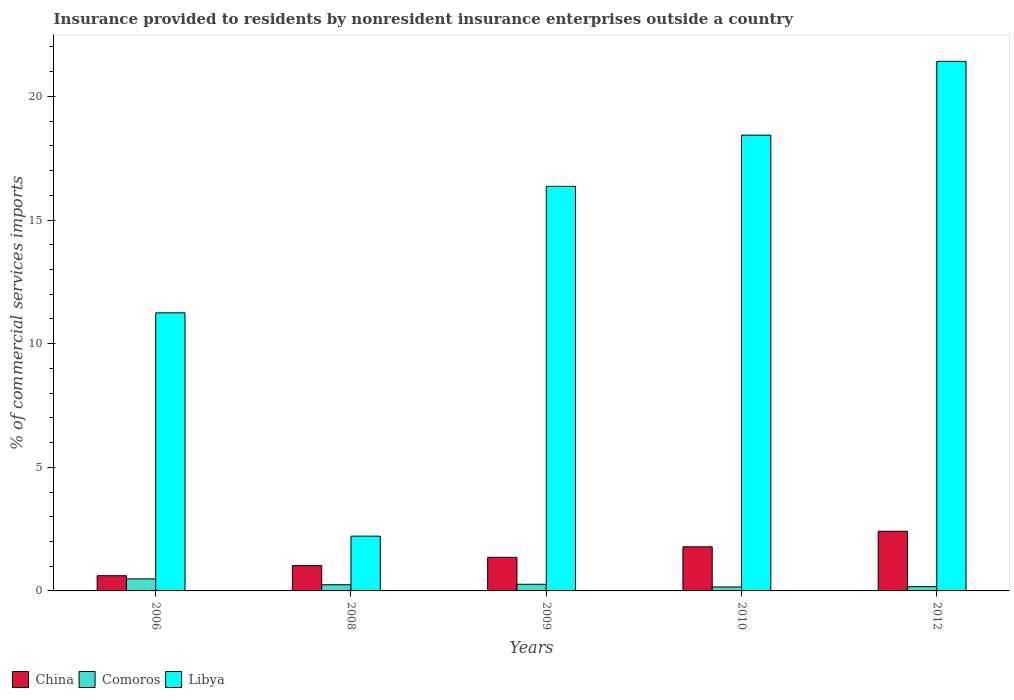How many bars are there on the 2nd tick from the left?
Offer a terse response. 3. What is the Insurance provided to residents in China in 2009?
Offer a terse response. 1.36. Across all years, what is the maximum Insurance provided to residents in China?
Your answer should be very brief. 2.41. Across all years, what is the minimum Insurance provided to residents in Libya?
Ensure brevity in your answer.  2.21. In which year was the Insurance provided to residents in China maximum?
Provide a short and direct response. 2012. In which year was the Insurance provided to residents in China minimum?
Provide a succinct answer. 2006. What is the total Insurance provided to residents in China in the graph?
Offer a terse response. 7.19. What is the difference between the Insurance provided to residents in China in 2006 and that in 2008?
Offer a terse response. -0.41. What is the difference between the Insurance provided to residents in Libya in 2009 and the Insurance provided to residents in Comoros in 2012?
Make the answer very short. 16.19. What is the average Insurance provided to residents in China per year?
Ensure brevity in your answer.  1.44. In the year 2010, what is the difference between the Insurance provided to residents in Libya and Insurance provided to residents in Comoros?
Give a very brief answer. 18.27. What is the ratio of the Insurance provided to residents in Libya in 2009 to that in 2010?
Your answer should be very brief. 0.89. Is the Insurance provided to residents in Libya in 2006 less than that in 2009?
Provide a succinct answer. Yes. Is the difference between the Insurance provided to residents in Libya in 2009 and 2010 greater than the difference between the Insurance provided to residents in Comoros in 2009 and 2010?
Offer a very short reply. No. What is the difference between the highest and the second highest Insurance provided to residents in China?
Give a very brief answer. 0.63. What is the difference between the highest and the lowest Insurance provided to residents in China?
Ensure brevity in your answer.  1.8. What does the 1st bar from the right in 2008 represents?
Make the answer very short. Libya. How many bars are there?
Keep it short and to the point. 15. Are all the bars in the graph horizontal?
Your answer should be compact. No. How many years are there in the graph?
Make the answer very short. 5. Where does the legend appear in the graph?
Your answer should be compact. Bottom left. How many legend labels are there?
Give a very brief answer. 3. How are the legend labels stacked?
Your answer should be very brief. Horizontal. What is the title of the graph?
Your answer should be compact. Insurance provided to residents by nonresident insurance enterprises outside a country. Does "Lower middle income" appear as one of the legend labels in the graph?
Offer a very short reply. No. What is the label or title of the X-axis?
Make the answer very short. Years. What is the label or title of the Y-axis?
Keep it short and to the point. % of commercial services imports. What is the % of commercial services imports of China in 2006?
Make the answer very short. 0.62. What is the % of commercial services imports in Comoros in 2006?
Your response must be concise. 0.49. What is the % of commercial services imports in Libya in 2006?
Keep it short and to the point. 11.25. What is the % of commercial services imports in China in 2008?
Ensure brevity in your answer.  1.02. What is the % of commercial services imports in Comoros in 2008?
Your answer should be very brief. 0.25. What is the % of commercial services imports of Libya in 2008?
Keep it short and to the point. 2.21. What is the % of commercial services imports in China in 2009?
Your response must be concise. 1.36. What is the % of commercial services imports in Comoros in 2009?
Your answer should be compact. 0.27. What is the % of commercial services imports in Libya in 2009?
Your answer should be very brief. 16.36. What is the % of commercial services imports of China in 2010?
Make the answer very short. 1.78. What is the % of commercial services imports in Comoros in 2010?
Give a very brief answer. 0.16. What is the % of commercial services imports in Libya in 2010?
Give a very brief answer. 18.43. What is the % of commercial services imports of China in 2012?
Your response must be concise. 2.41. What is the % of commercial services imports in Comoros in 2012?
Your response must be concise. 0.17. What is the % of commercial services imports of Libya in 2012?
Offer a very short reply. 21.42. Across all years, what is the maximum % of commercial services imports of China?
Give a very brief answer. 2.41. Across all years, what is the maximum % of commercial services imports of Comoros?
Ensure brevity in your answer.  0.49. Across all years, what is the maximum % of commercial services imports in Libya?
Your answer should be compact. 21.42. Across all years, what is the minimum % of commercial services imports of China?
Give a very brief answer. 0.62. Across all years, what is the minimum % of commercial services imports in Comoros?
Ensure brevity in your answer.  0.16. Across all years, what is the minimum % of commercial services imports in Libya?
Ensure brevity in your answer.  2.21. What is the total % of commercial services imports of China in the graph?
Ensure brevity in your answer.  7.19. What is the total % of commercial services imports of Comoros in the graph?
Your response must be concise. 1.34. What is the total % of commercial services imports in Libya in the graph?
Make the answer very short. 69.68. What is the difference between the % of commercial services imports in China in 2006 and that in 2008?
Offer a very short reply. -0.41. What is the difference between the % of commercial services imports in Comoros in 2006 and that in 2008?
Ensure brevity in your answer.  0.24. What is the difference between the % of commercial services imports of Libya in 2006 and that in 2008?
Ensure brevity in your answer.  9.03. What is the difference between the % of commercial services imports in China in 2006 and that in 2009?
Provide a succinct answer. -0.74. What is the difference between the % of commercial services imports of Comoros in 2006 and that in 2009?
Your answer should be very brief. 0.22. What is the difference between the % of commercial services imports in Libya in 2006 and that in 2009?
Your response must be concise. -5.12. What is the difference between the % of commercial services imports in China in 2006 and that in 2010?
Your response must be concise. -1.17. What is the difference between the % of commercial services imports in Comoros in 2006 and that in 2010?
Provide a succinct answer. 0.33. What is the difference between the % of commercial services imports in Libya in 2006 and that in 2010?
Provide a succinct answer. -7.19. What is the difference between the % of commercial services imports of China in 2006 and that in 2012?
Provide a succinct answer. -1.8. What is the difference between the % of commercial services imports of Comoros in 2006 and that in 2012?
Provide a succinct answer. 0.32. What is the difference between the % of commercial services imports of Libya in 2006 and that in 2012?
Provide a succinct answer. -10.17. What is the difference between the % of commercial services imports of China in 2008 and that in 2009?
Provide a succinct answer. -0.34. What is the difference between the % of commercial services imports of Comoros in 2008 and that in 2009?
Ensure brevity in your answer.  -0.02. What is the difference between the % of commercial services imports in Libya in 2008 and that in 2009?
Your answer should be compact. -14.15. What is the difference between the % of commercial services imports of China in 2008 and that in 2010?
Offer a terse response. -0.76. What is the difference between the % of commercial services imports of Comoros in 2008 and that in 2010?
Make the answer very short. 0.09. What is the difference between the % of commercial services imports in Libya in 2008 and that in 2010?
Provide a short and direct response. -16.22. What is the difference between the % of commercial services imports in China in 2008 and that in 2012?
Your answer should be compact. -1.39. What is the difference between the % of commercial services imports of Comoros in 2008 and that in 2012?
Offer a terse response. 0.08. What is the difference between the % of commercial services imports of Libya in 2008 and that in 2012?
Make the answer very short. -19.2. What is the difference between the % of commercial services imports in China in 2009 and that in 2010?
Offer a terse response. -0.42. What is the difference between the % of commercial services imports in Comoros in 2009 and that in 2010?
Your answer should be very brief. 0.11. What is the difference between the % of commercial services imports of Libya in 2009 and that in 2010?
Make the answer very short. -2.07. What is the difference between the % of commercial services imports of China in 2009 and that in 2012?
Your answer should be very brief. -1.05. What is the difference between the % of commercial services imports of Comoros in 2009 and that in 2012?
Offer a terse response. 0.1. What is the difference between the % of commercial services imports of Libya in 2009 and that in 2012?
Make the answer very short. -5.06. What is the difference between the % of commercial services imports of China in 2010 and that in 2012?
Keep it short and to the point. -0.63. What is the difference between the % of commercial services imports in Comoros in 2010 and that in 2012?
Offer a very short reply. -0.01. What is the difference between the % of commercial services imports in Libya in 2010 and that in 2012?
Ensure brevity in your answer.  -2.98. What is the difference between the % of commercial services imports in China in 2006 and the % of commercial services imports in Comoros in 2008?
Make the answer very short. 0.37. What is the difference between the % of commercial services imports in China in 2006 and the % of commercial services imports in Libya in 2008?
Offer a very short reply. -1.6. What is the difference between the % of commercial services imports in Comoros in 2006 and the % of commercial services imports in Libya in 2008?
Provide a short and direct response. -1.73. What is the difference between the % of commercial services imports of China in 2006 and the % of commercial services imports of Comoros in 2009?
Offer a terse response. 0.35. What is the difference between the % of commercial services imports of China in 2006 and the % of commercial services imports of Libya in 2009?
Provide a succinct answer. -15.75. What is the difference between the % of commercial services imports of Comoros in 2006 and the % of commercial services imports of Libya in 2009?
Your answer should be compact. -15.88. What is the difference between the % of commercial services imports in China in 2006 and the % of commercial services imports in Comoros in 2010?
Provide a short and direct response. 0.46. What is the difference between the % of commercial services imports in China in 2006 and the % of commercial services imports in Libya in 2010?
Your answer should be very brief. -17.82. What is the difference between the % of commercial services imports of Comoros in 2006 and the % of commercial services imports of Libya in 2010?
Your answer should be compact. -17.95. What is the difference between the % of commercial services imports in China in 2006 and the % of commercial services imports in Comoros in 2012?
Offer a very short reply. 0.44. What is the difference between the % of commercial services imports of China in 2006 and the % of commercial services imports of Libya in 2012?
Make the answer very short. -20.8. What is the difference between the % of commercial services imports in Comoros in 2006 and the % of commercial services imports in Libya in 2012?
Your answer should be compact. -20.93. What is the difference between the % of commercial services imports of China in 2008 and the % of commercial services imports of Comoros in 2009?
Your answer should be compact. 0.75. What is the difference between the % of commercial services imports of China in 2008 and the % of commercial services imports of Libya in 2009?
Make the answer very short. -15.34. What is the difference between the % of commercial services imports of Comoros in 2008 and the % of commercial services imports of Libya in 2009?
Keep it short and to the point. -16.11. What is the difference between the % of commercial services imports of China in 2008 and the % of commercial services imports of Comoros in 2010?
Provide a succinct answer. 0.86. What is the difference between the % of commercial services imports of China in 2008 and the % of commercial services imports of Libya in 2010?
Offer a very short reply. -17.41. What is the difference between the % of commercial services imports in Comoros in 2008 and the % of commercial services imports in Libya in 2010?
Give a very brief answer. -18.18. What is the difference between the % of commercial services imports in China in 2008 and the % of commercial services imports in Comoros in 2012?
Your response must be concise. 0.85. What is the difference between the % of commercial services imports of China in 2008 and the % of commercial services imports of Libya in 2012?
Provide a succinct answer. -20.4. What is the difference between the % of commercial services imports of Comoros in 2008 and the % of commercial services imports of Libya in 2012?
Your answer should be very brief. -21.17. What is the difference between the % of commercial services imports of China in 2009 and the % of commercial services imports of Comoros in 2010?
Your response must be concise. 1.2. What is the difference between the % of commercial services imports of China in 2009 and the % of commercial services imports of Libya in 2010?
Your answer should be very brief. -17.08. What is the difference between the % of commercial services imports of Comoros in 2009 and the % of commercial services imports of Libya in 2010?
Your answer should be compact. -18.17. What is the difference between the % of commercial services imports in China in 2009 and the % of commercial services imports in Comoros in 2012?
Provide a succinct answer. 1.19. What is the difference between the % of commercial services imports in China in 2009 and the % of commercial services imports in Libya in 2012?
Ensure brevity in your answer.  -20.06. What is the difference between the % of commercial services imports in Comoros in 2009 and the % of commercial services imports in Libya in 2012?
Offer a very short reply. -21.15. What is the difference between the % of commercial services imports of China in 2010 and the % of commercial services imports of Comoros in 2012?
Provide a short and direct response. 1.61. What is the difference between the % of commercial services imports of China in 2010 and the % of commercial services imports of Libya in 2012?
Provide a short and direct response. -19.64. What is the difference between the % of commercial services imports of Comoros in 2010 and the % of commercial services imports of Libya in 2012?
Your answer should be very brief. -21.26. What is the average % of commercial services imports in China per year?
Give a very brief answer. 1.44. What is the average % of commercial services imports in Comoros per year?
Provide a succinct answer. 0.27. What is the average % of commercial services imports in Libya per year?
Provide a short and direct response. 13.94. In the year 2006, what is the difference between the % of commercial services imports in China and % of commercial services imports in Comoros?
Offer a very short reply. 0.13. In the year 2006, what is the difference between the % of commercial services imports of China and % of commercial services imports of Libya?
Keep it short and to the point. -10.63. In the year 2006, what is the difference between the % of commercial services imports in Comoros and % of commercial services imports in Libya?
Ensure brevity in your answer.  -10.76. In the year 2008, what is the difference between the % of commercial services imports of China and % of commercial services imports of Comoros?
Your answer should be very brief. 0.77. In the year 2008, what is the difference between the % of commercial services imports in China and % of commercial services imports in Libya?
Ensure brevity in your answer.  -1.19. In the year 2008, what is the difference between the % of commercial services imports in Comoros and % of commercial services imports in Libya?
Your response must be concise. -1.97. In the year 2009, what is the difference between the % of commercial services imports of China and % of commercial services imports of Comoros?
Make the answer very short. 1.09. In the year 2009, what is the difference between the % of commercial services imports in China and % of commercial services imports in Libya?
Offer a terse response. -15. In the year 2009, what is the difference between the % of commercial services imports in Comoros and % of commercial services imports in Libya?
Give a very brief answer. -16.09. In the year 2010, what is the difference between the % of commercial services imports of China and % of commercial services imports of Comoros?
Your answer should be very brief. 1.62. In the year 2010, what is the difference between the % of commercial services imports in China and % of commercial services imports in Libya?
Your answer should be compact. -16.65. In the year 2010, what is the difference between the % of commercial services imports in Comoros and % of commercial services imports in Libya?
Your answer should be very brief. -18.27. In the year 2012, what is the difference between the % of commercial services imports of China and % of commercial services imports of Comoros?
Your answer should be compact. 2.24. In the year 2012, what is the difference between the % of commercial services imports in China and % of commercial services imports in Libya?
Offer a terse response. -19.01. In the year 2012, what is the difference between the % of commercial services imports in Comoros and % of commercial services imports in Libya?
Offer a very short reply. -21.25. What is the ratio of the % of commercial services imports in China in 2006 to that in 2008?
Your answer should be very brief. 0.6. What is the ratio of the % of commercial services imports in Comoros in 2006 to that in 2008?
Give a very brief answer. 1.95. What is the ratio of the % of commercial services imports in Libya in 2006 to that in 2008?
Your response must be concise. 5.08. What is the ratio of the % of commercial services imports in China in 2006 to that in 2009?
Provide a short and direct response. 0.45. What is the ratio of the % of commercial services imports of Comoros in 2006 to that in 2009?
Your response must be concise. 1.81. What is the ratio of the % of commercial services imports in Libya in 2006 to that in 2009?
Your answer should be very brief. 0.69. What is the ratio of the % of commercial services imports in China in 2006 to that in 2010?
Your answer should be compact. 0.34. What is the ratio of the % of commercial services imports of Comoros in 2006 to that in 2010?
Give a very brief answer. 3.05. What is the ratio of the % of commercial services imports in Libya in 2006 to that in 2010?
Your answer should be compact. 0.61. What is the ratio of the % of commercial services imports of China in 2006 to that in 2012?
Offer a very short reply. 0.26. What is the ratio of the % of commercial services imports in Comoros in 2006 to that in 2012?
Provide a succinct answer. 2.85. What is the ratio of the % of commercial services imports in Libya in 2006 to that in 2012?
Offer a terse response. 0.53. What is the ratio of the % of commercial services imports of China in 2008 to that in 2009?
Provide a short and direct response. 0.75. What is the ratio of the % of commercial services imports in Comoros in 2008 to that in 2009?
Your response must be concise. 0.93. What is the ratio of the % of commercial services imports of Libya in 2008 to that in 2009?
Provide a succinct answer. 0.14. What is the ratio of the % of commercial services imports of China in 2008 to that in 2010?
Your response must be concise. 0.57. What is the ratio of the % of commercial services imports of Comoros in 2008 to that in 2010?
Make the answer very short. 1.56. What is the ratio of the % of commercial services imports in Libya in 2008 to that in 2010?
Provide a succinct answer. 0.12. What is the ratio of the % of commercial services imports of China in 2008 to that in 2012?
Your answer should be very brief. 0.42. What is the ratio of the % of commercial services imports in Comoros in 2008 to that in 2012?
Keep it short and to the point. 1.46. What is the ratio of the % of commercial services imports of Libya in 2008 to that in 2012?
Make the answer very short. 0.1. What is the ratio of the % of commercial services imports of China in 2009 to that in 2010?
Your answer should be very brief. 0.76. What is the ratio of the % of commercial services imports of Comoros in 2009 to that in 2010?
Offer a very short reply. 1.68. What is the ratio of the % of commercial services imports in Libya in 2009 to that in 2010?
Provide a short and direct response. 0.89. What is the ratio of the % of commercial services imports in China in 2009 to that in 2012?
Provide a short and direct response. 0.56. What is the ratio of the % of commercial services imports in Comoros in 2009 to that in 2012?
Give a very brief answer. 1.58. What is the ratio of the % of commercial services imports in Libya in 2009 to that in 2012?
Your answer should be very brief. 0.76. What is the ratio of the % of commercial services imports of China in 2010 to that in 2012?
Offer a terse response. 0.74. What is the ratio of the % of commercial services imports of Comoros in 2010 to that in 2012?
Keep it short and to the point. 0.94. What is the ratio of the % of commercial services imports of Libya in 2010 to that in 2012?
Offer a terse response. 0.86. What is the difference between the highest and the second highest % of commercial services imports of China?
Ensure brevity in your answer.  0.63. What is the difference between the highest and the second highest % of commercial services imports of Comoros?
Your response must be concise. 0.22. What is the difference between the highest and the second highest % of commercial services imports of Libya?
Keep it short and to the point. 2.98. What is the difference between the highest and the lowest % of commercial services imports of China?
Ensure brevity in your answer.  1.8. What is the difference between the highest and the lowest % of commercial services imports of Comoros?
Provide a short and direct response. 0.33. What is the difference between the highest and the lowest % of commercial services imports in Libya?
Your response must be concise. 19.2. 